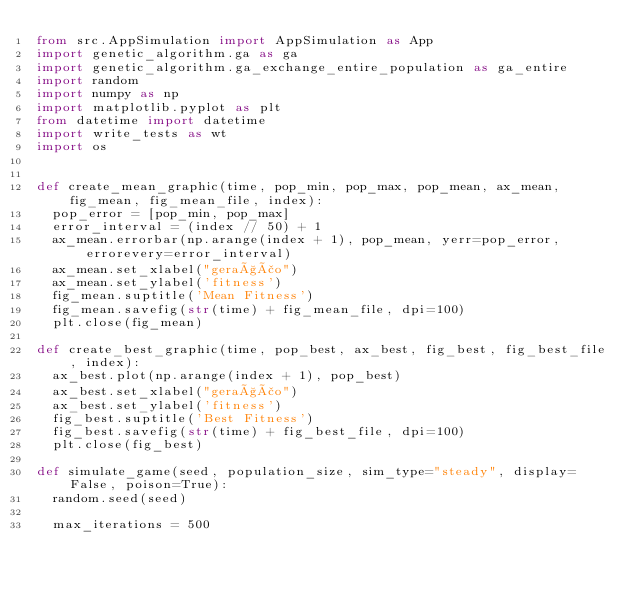<code> <loc_0><loc_0><loc_500><loc_500><_Python_>from src.AppSimulation import AppSimulation as App
import genetic_algorithm.ga as ga
import genetic_algorithm.ga_exchange_entire_population as ga_entire
import random
import numpy as np
import matplotlib.pyplot as plt
from datetime import datetime
import write_tests as wt
import os


def create_mean_graphic(time, pop_min, pop_max, pop_mean, ax_mean, fig_mean, fig_mean_file, index):
	pop_error = [pop_min, pop_max]
	error_interval = (index // 50) + 1
	ax_mean.errorbar(np.arange(index + 1), pop_mean, yerr=pop_error, errorevery=error_interval)
	ax_mean.set_xlabel("geração")
	ax_mean.set_ylabel('fitness')
	fig_mean.suptitle('Mean Fitness')
	fig_mean.savefig(str(time) + fig_mean_file, dpi=100)
	plt.close(fig_mean)

def create_best_graphic(time, pop_best, ax_best, fig_best, fig_best_file, index):
	ax_best.plot(np.arange(index + 1), pop_best)
	ax_best.set_xlabel("geração")
	ax_best.set_ylabel('fitness')
	fig_best.suptitle('Best Fitness')
	fig_best.savefig(str(time) + fig_best_file, dpi=100)
	plt.close(fig_best)

def simulate_game(seed, population_size, sim_type="steady", display=False, poison=True):
	random.seed(seed) 
	
	max_iterations = 500</code> 